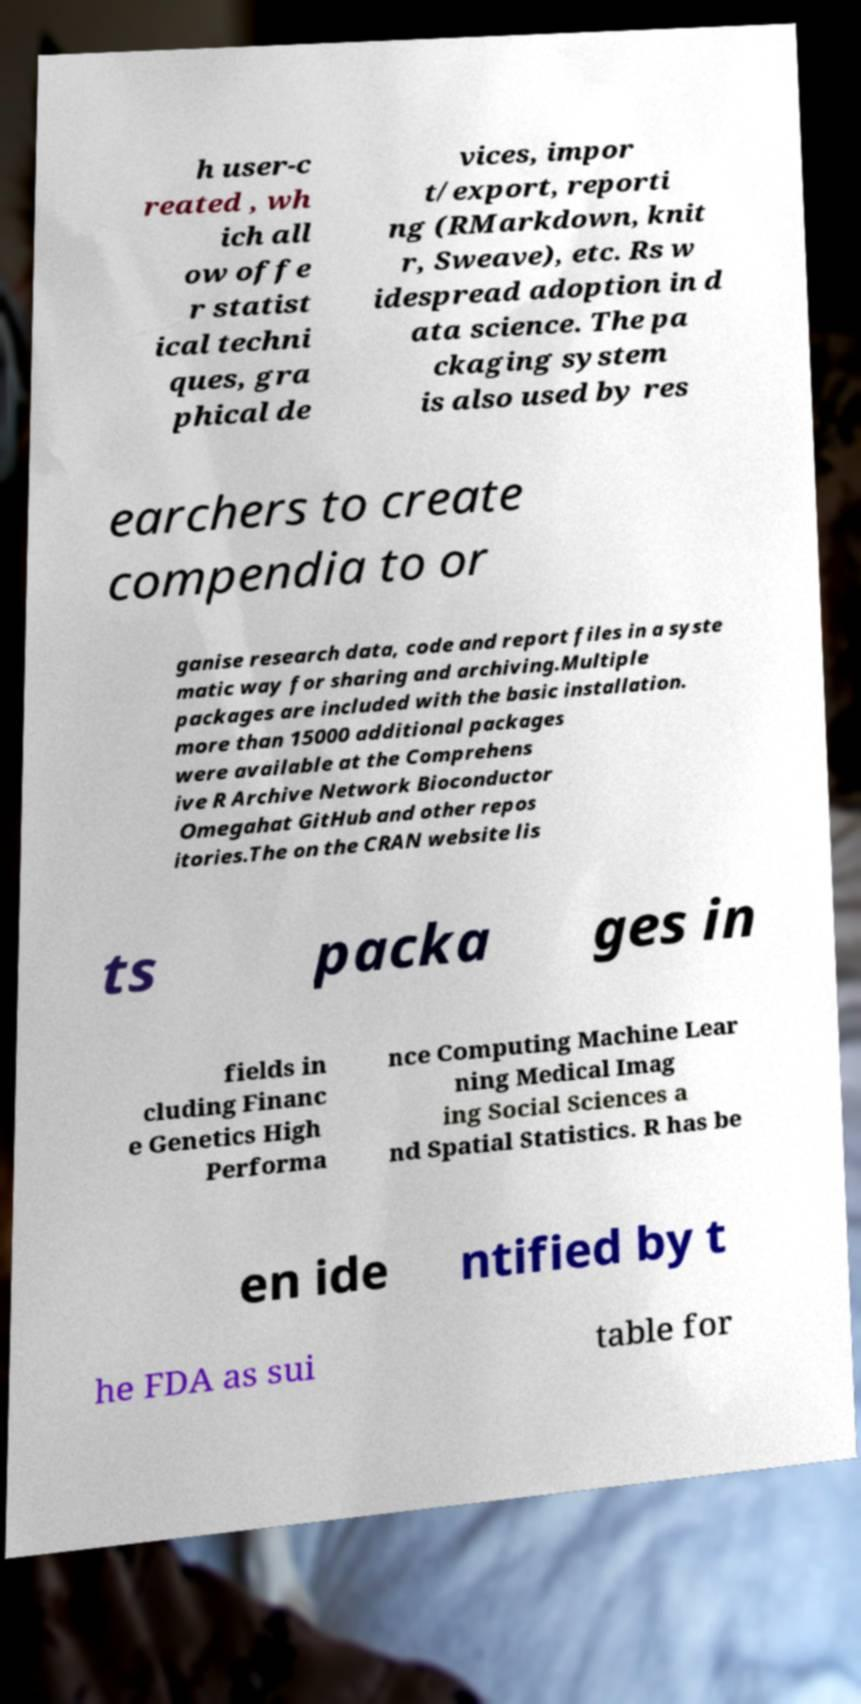Could you extract and type out the text from this image? h user-c reated , wh ich all ow offe r statist ical techni ques, gra phical de vices, impor t/export, reporti ng (RMarkdown, knit r, Sweave), etc. Rs w idespread adoption in d ata science. The pa ckaging system is also used by res earchers to create compendia to or ganise research data, code and report files in a syste matic way for sharing and archiving.Multiple packages are included with the basic installation. more than 15000 additional packages were available at the Comprehens ive R Archive Network Bioconductor Omegahat GitHub and other repos itories.The on the CRAN website lis ts packa ges in fields in cluding Financ e Genetics High Performa nce Computing Machine Lear ning Medical Imag ing Social Sciences a nd Spatial Statistics. R has be en ide ntified by t he FDA as sui table for 